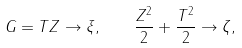<formula> <loc_0><loc_0><loc_500><loc_500>G = T Z \to \xi , \quad \frac { Z ^ { 2 } } { 2 } + \frac { T ^ { 2 } } { 2 } \to \zeta ,</formula> 